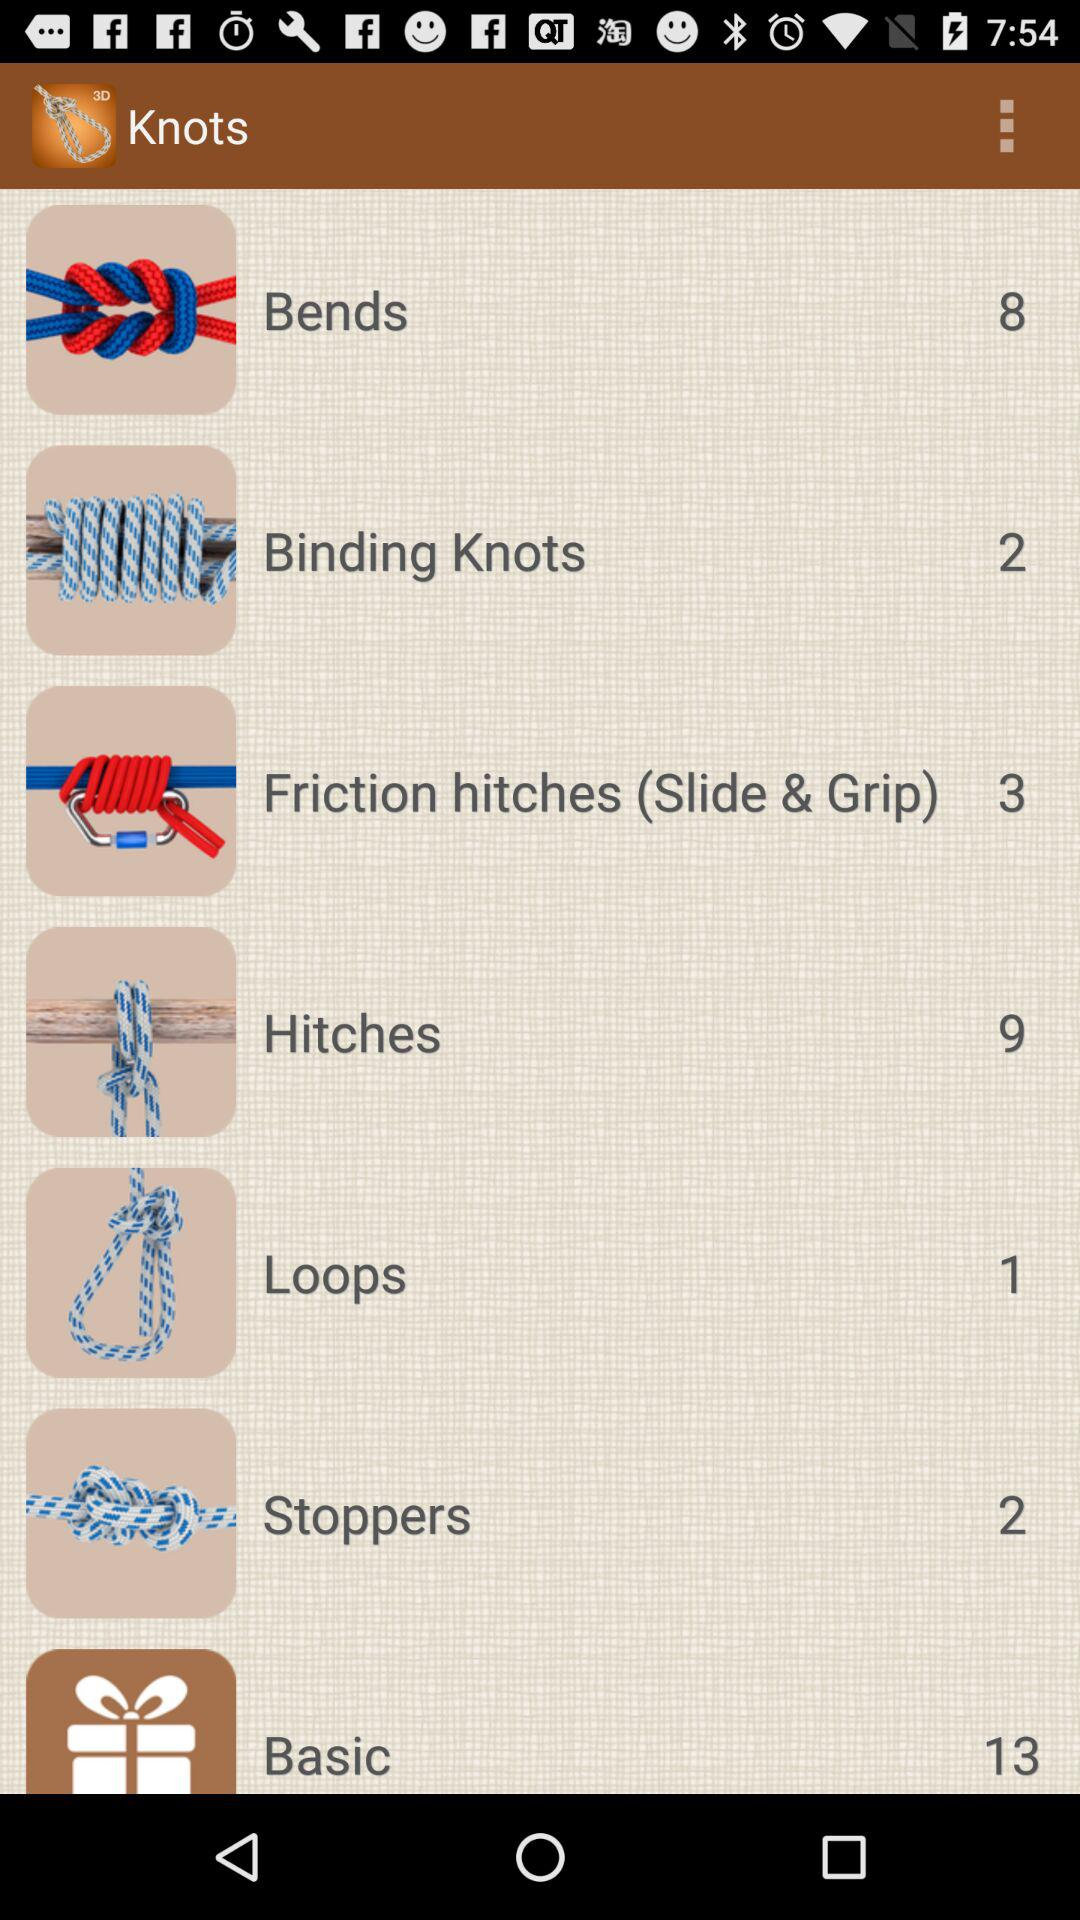What category has the highest number of knots? The category that has the highest number of knots is "Basic". 